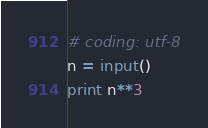Convert code to text. <code><loc_0><loc_0><loc_500><loc_500><_Python_># coding: utf-8
n = input()
print n**3</code> 